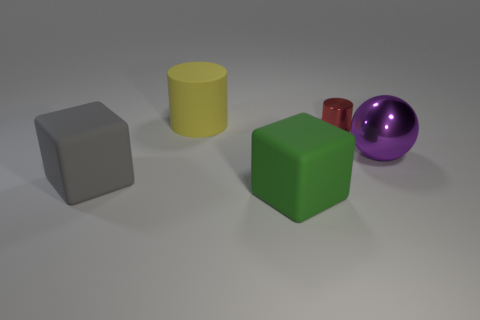What number of large things are both in front of the big rubber cylinder and left of the large purple metallic ball? After examining the image, it appears that there are two large items fitting the description: a gray cube and a green cube. They are positioned both to the left of the purple metallic ball and in front of the yellow rubber cylinder from the perspective shown in the image. 